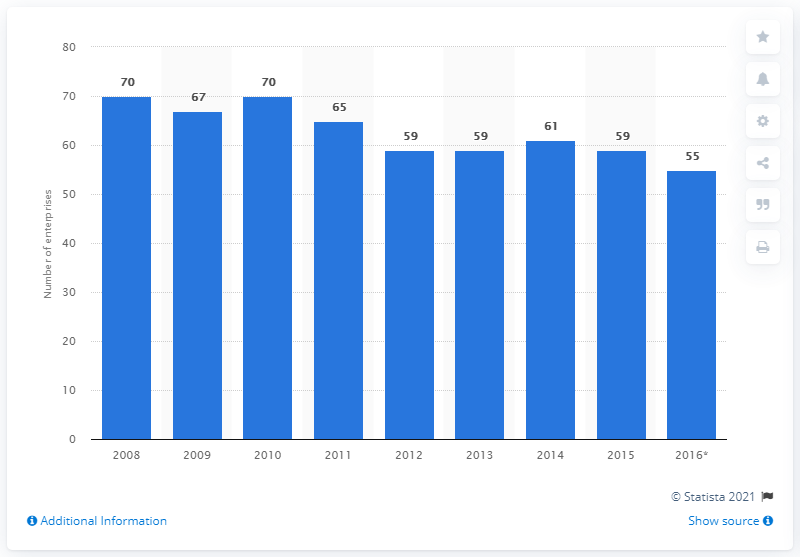Specify some key components in this picture. In 2015, there were 59 enterprises in Hungary that manufactured pharmaceutical preparations. 